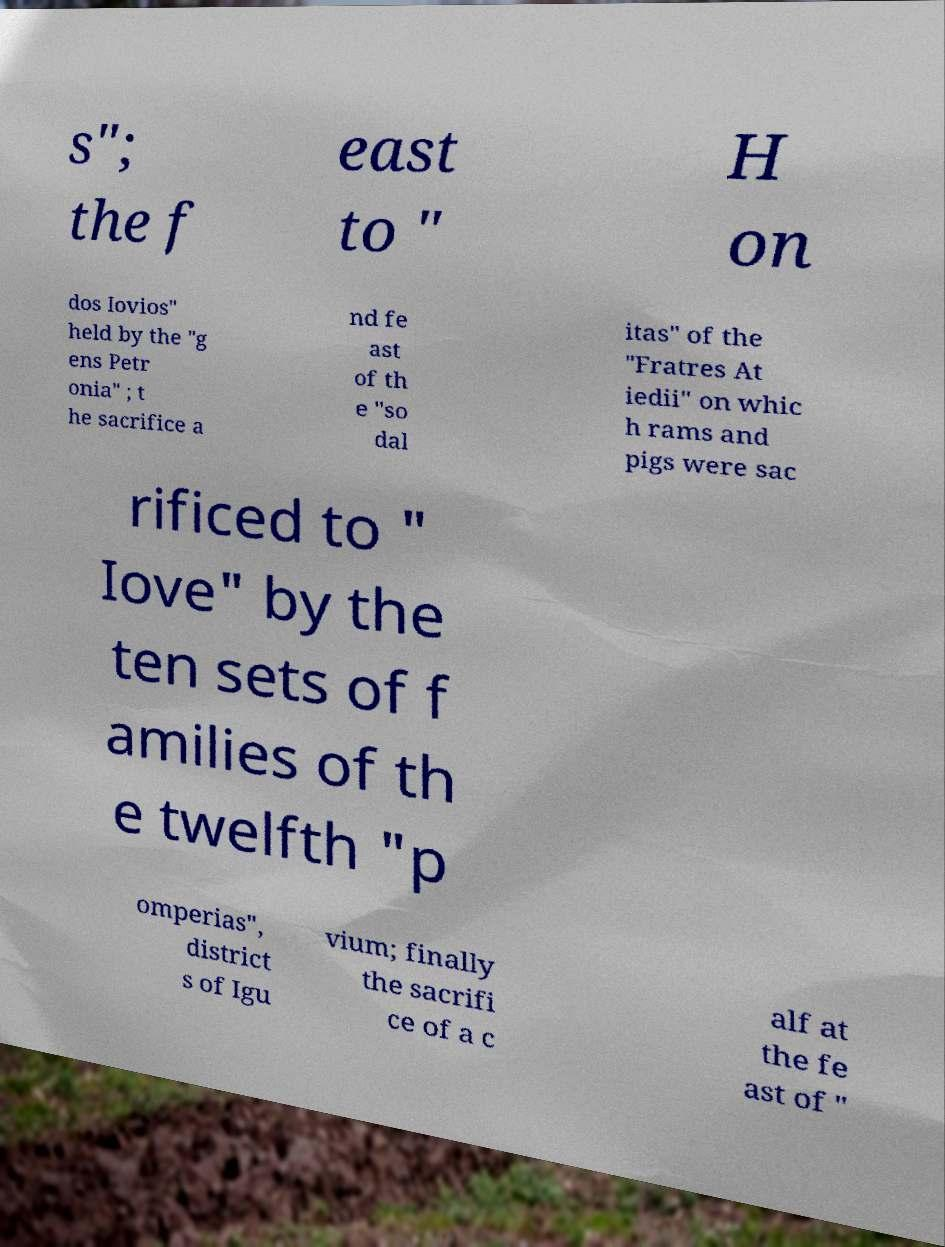Please identify and transcribe the text found in this image. s"; the f east to " H on dos Iovios" held by the "g ens Petr onia" ; t he sacrifice a nd fe ast of th e "so dal itas" of the "Fratres At iedii" on whic h rams and pigs were sac rificed to " Iove" by the ten sets of f amilies of th e twelfth "p omperias", district s of Igu vium; finally the sacrifi ce of a c alf at the fe ast of " 